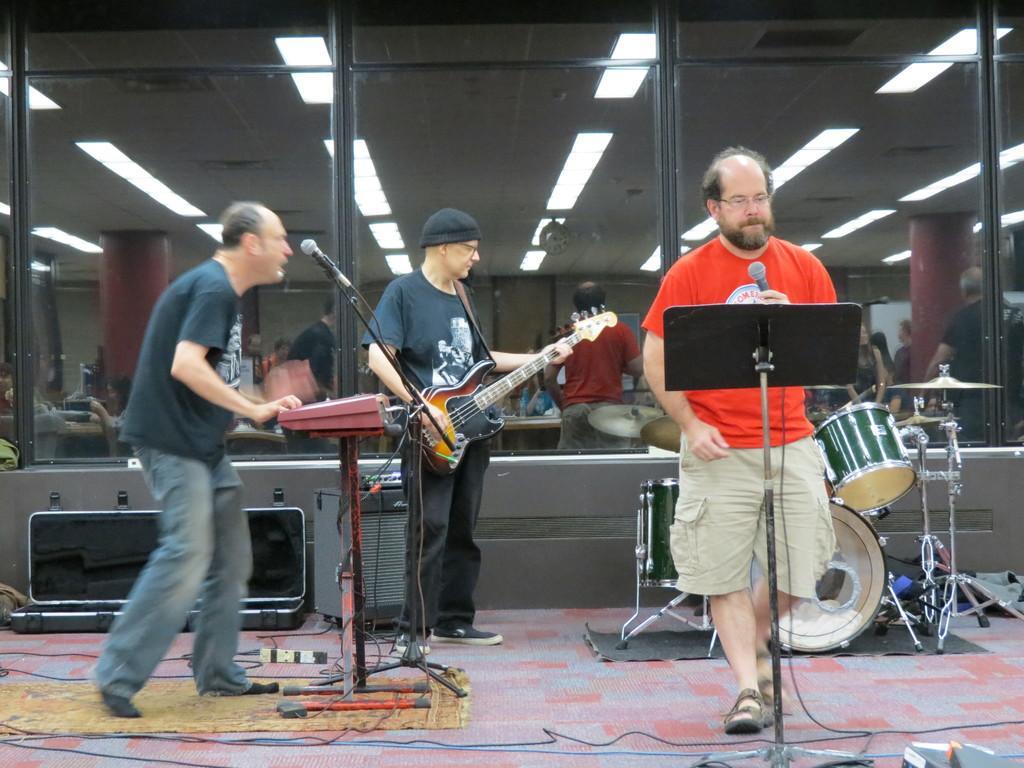In one or two sentences, can you explain what this image depicts? In the image we can see there are people who are standing and the man is playing casio another man is holding guitar in his hand and at the corner the man is holding mic in his hand and at the back there is a drum set. 